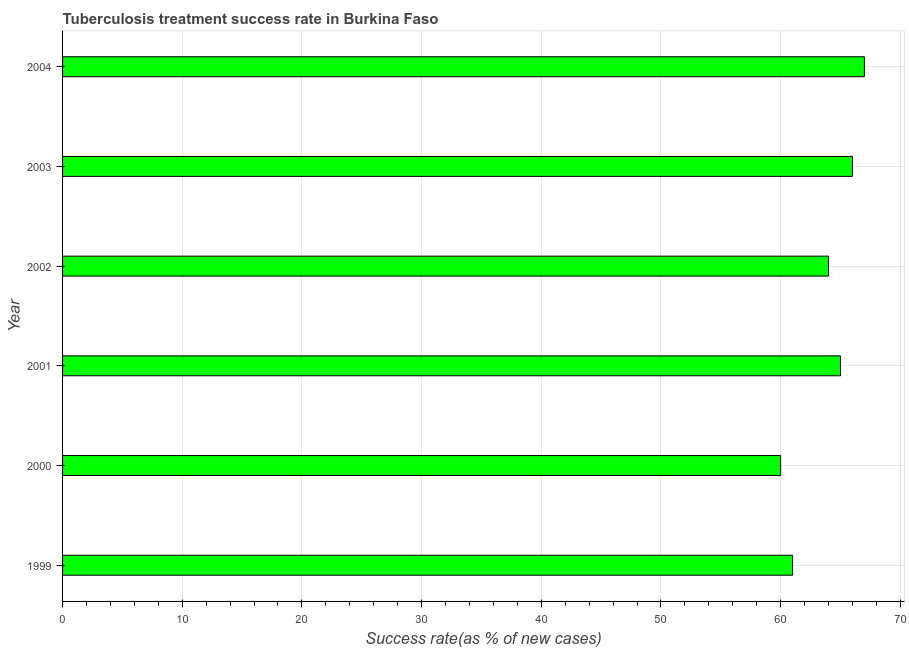What is the title of the graph?
Give a very brief answer. Tuberculosis treatment success rate in Burkina Faso. What is the label or title of the X-axis?
Your answer should be compact. Success rate(as % of new cases). What is the label or title of the Y-axis?
Give a very brief answer. Year. What is the tuberculosis treatment success rate in 2001?
Provide a short and direct response. 65. Across all years, what is the minimum tuberculosis treatment success rate?
Your answer should be very brief. 60. In which year was the tuberculosis treatment success rate maximum?
Your answer should be very brief. 2004. In which year was the tuberculosis treatment success rate minimum?
Ensure brevity in your answer.  2000. What is the sum of the tuberculosis treatment success rate?
Provide a succinct answer. 383. What is the difference between the tuberculosis treatment success rate in 1999 and 2000?
Give a very brief answer. 1. What is the median tuberculosis treatment success rate?
Your response must be concise. 64.5. In how many years, is the tuberculosis treatment success rate greater than 42 %?
Make the answer very short. 6. What is the ratio of the tuberculosis treatment success rate in 2000 to that in 2002?
Your response must be concise. 0.94. Is the tuberculosis treatment success rate in 2000 less than that in 2003?
Your answer should be compact. Yes. Is the difference between the tuberculosis treatment success rate in 1999 and 2001 greater than the difference between any two years?
Keep it short and to the point. No. Is the sum of the tuberculosis treatment success rate in 2001 and 2004 greater than the maximum tuberculosis treatment success rate across all years?
Provide a succinct answer. Yes. What is the difference between the highest and the lowest tuberculosis treatment success rate?
Your response must be concise. 7. In how many years, is the tuberculosis treatment success rate greater than the average tuberculosis treatment success rate taken over all years?
Offer a terse response. 4. How many bars are there?
Your response must be concise. 6. Are the values on the major ticks of X-axis written in scientific E-notation?
Keep it short and to the point. No. What is the Success rate(as % of new cases) in 2003?
Offer a terse response. 66. What is the Success rate(as % of new cases) in 2004?
Keep it short and to the point. 67. What is the difference between the Success rate(as % of new cases) in 1999 and 2001?
Provide a succinct answer. -4. What is the difference between the Success rate(as % of new cases) in 1999 and 2002?
Your response must be concise. -3. What is the difference between the Success rate(as % of new cases) in 1999 and 2003?
Ensure brevity in your answer.  -5. What is the difference between the Success rate(as % of new cases) in 2000 and 2001?
Ensure brevity in your answer.  -5. What is the difference between the Success rate(as % of new cases) in 2000 and 2002?
Your answer should be very brief. -4. What is the difference between the Success rate(as % of new cases) in 2000 and 2004?
Give a very brief answer. -7. What is the difference between the Success rate(as % of new cases) in 2001 and 2004?
Provide a succinct answer. -2. What is the difference between the Success rate(as % of new cases) in 2003 and 2004?
Ensure brevity in your answer.  -1. What is the ratio of the Success rate(as % of new cases) in 1999 to that in 2001?
Provide a succinct answer. 0.94. What is the ratio of the Success rate(as % of new cases) in 1999 to that in 2002?
Provide a succinct answer. 0.95. What is the ratio of the Success rate(as % of new cases) in 1999 to that in 2003?
Ensure brevity in your answer.  0.92. What is the ratio of the Success rate(as % of new cases) in 1999 to that in 2004?
Your response must be concise. 0.91. What is the ratio of the Success rate(as % of new cases) in 2000 to that in 2001?
Give a very brief answer. 0.92. What is the ratio of the Success rate(as % of new cases) in 2000 to that in 2002?
Offer a very short reply. 0.94. What is the ratio of the Success rate(as % of new cases) in 2000 to that in 2003?
Your answer should be very brief. 0.91. What is the ratio of the Success rate(as % of new cases) in 2000 to that in 2004?
Your answer should be very brief. 0.9. What is the ratio of the Success rate(as % of new cases) in 2002 to that in 2003?
Offer a very short reply. 0.97. What is the ratio of the Success rate(as % of new cases) in 2002 to that in 2004?
Your answer should be very brief. 0.95. 